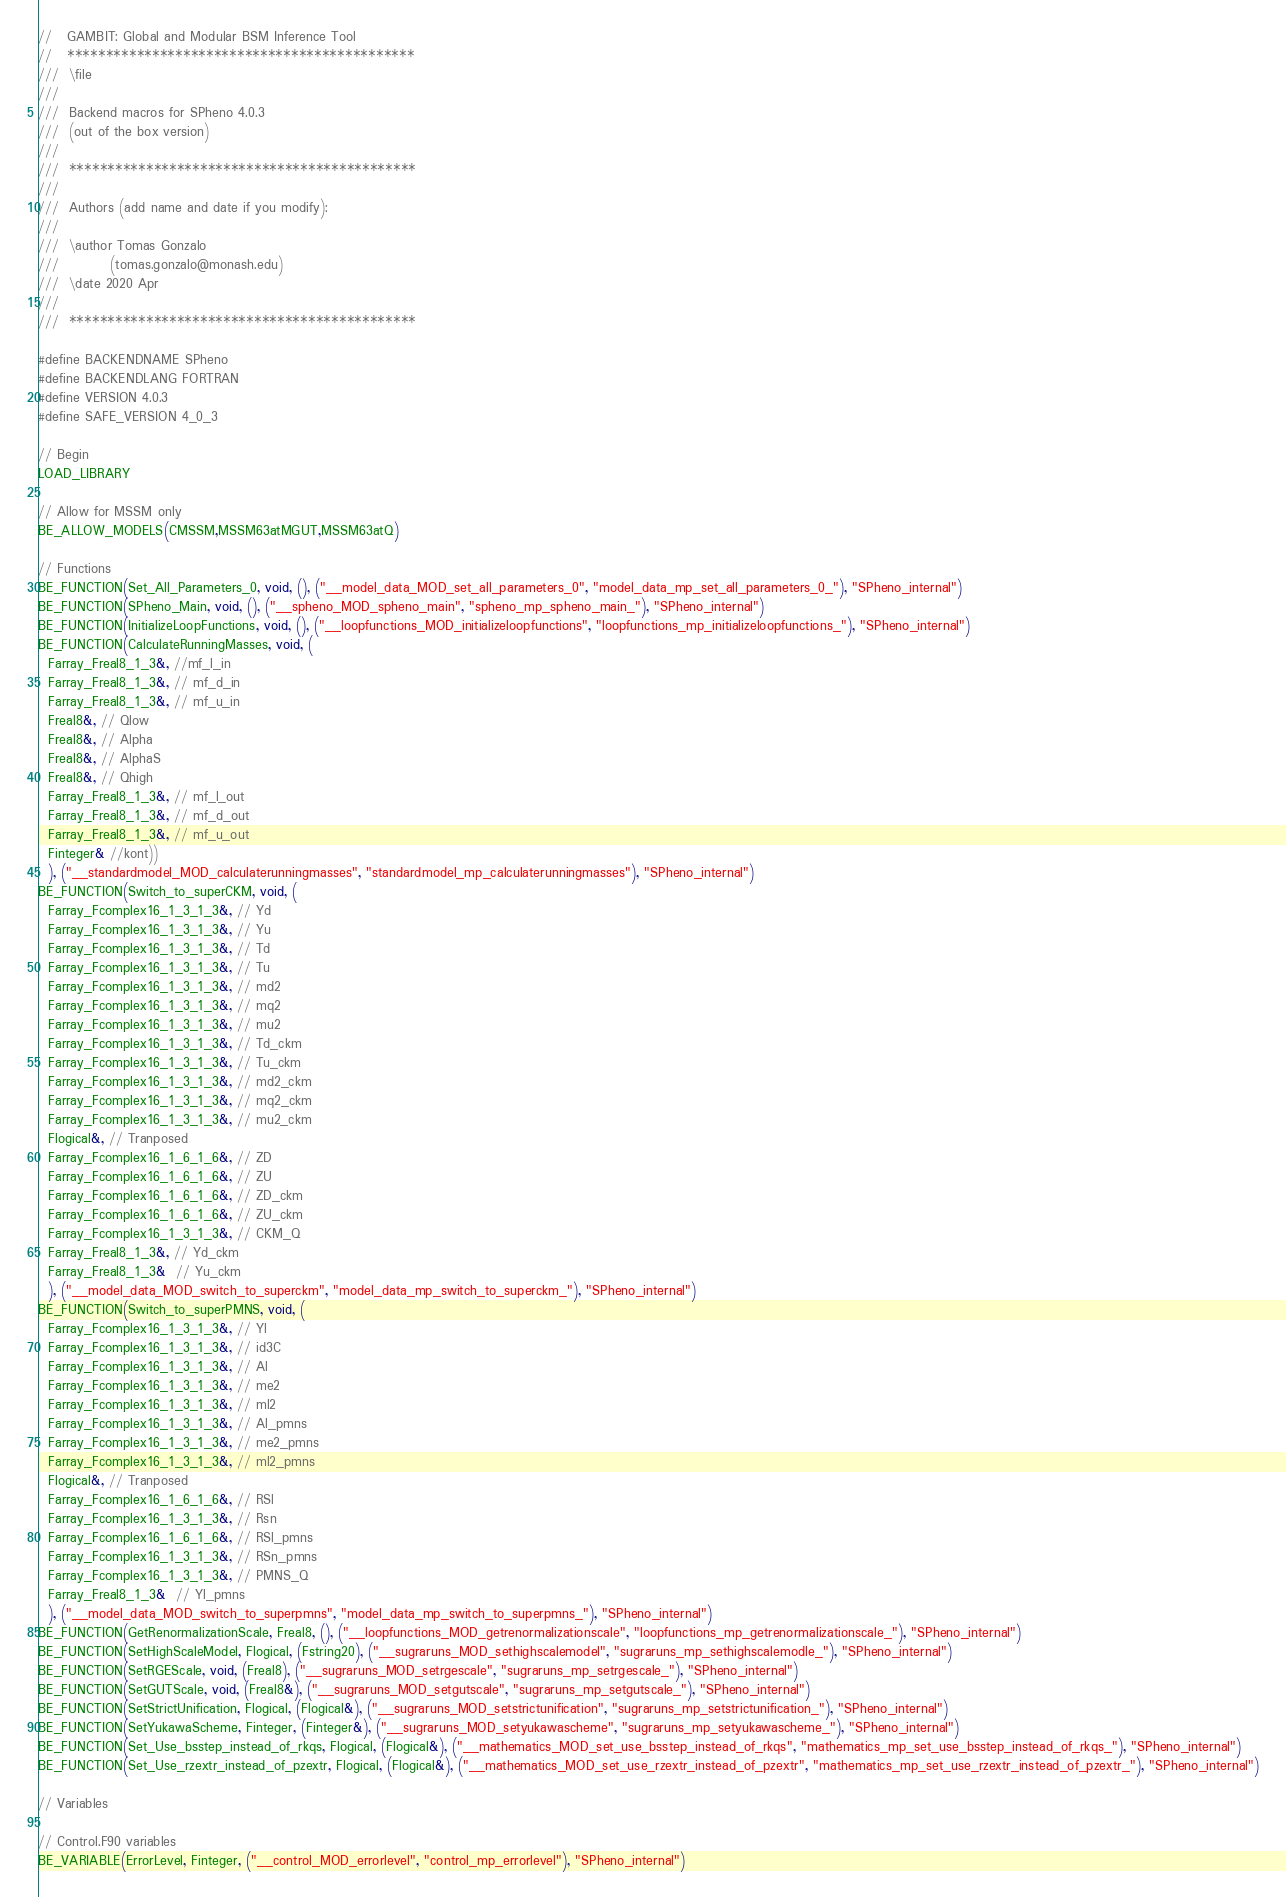Convert code to text. <code><loc_0><loc_0><loc_500><loc_500><_C++_>//   GAMBIT: Global and Modular BSM Inference Tool
//   *********************************************
///  \file
///
///  Backend macros for SPheno 4.0.3
///  (out of the box version)
///
///  *********************************************
///
///  Authors (add name and date if you modify):
///
///  \author Tomas Gonzalo
///          (tomas.gonzalo@monash.edu)
///  \date 2020 Apr
///
///  *********************************************

#define BACKENDNAME SPheno
#define BACKENDLANG FORTRAN
#define VERSION 4.0.3
#define SAFE_VERSION 4_0_3

// Begin
LOAD_LIBRARY

// Allow for MSSM only
BE_ALLOW_MODELS(CMSSM,MSSM63atMGUT,MSSM63atQ)

// Functions
BE_FUNCTION(Set_All_Parameters_0, void, (), ("__model_data_MOD_set_all_parameters_0", "model_data_mp_set_all_parameters_0_"), "SPheno_internal")
BE_FUNCTION(SPheno_Main, void, (), ("__spheno_MOD_spheno_main", "spheno_mp_spheno_main_"), "SPheno_internal")
BE_FUNCTION(InitializeLoopFunctions, void, (), ("__loopfunctions_MOD_initializeloopfunctions", "loopfunctions_mp_initializeloopfunctions_"), "SPheno_internal")
BE_FUNCTION(CalculateRunningMasses, void, (
  Farray_Freal8_1_3&, //mf_l_in
  Farray_Freal8_1_3&, // mf_d_in
  Farray_Freal8_1_3&, // mf_u_in
  Freal8&, // Qlow
  Freal8&, // Alpha
  Freal8&, // AlphaS
  Freal8&, // Qhigh
  Farray_Freal8_1_3&, // mf_l_out
  Farray_Freal8_1_3&, // mf_d_out
  Farray_Freal8_1_3&, // mf_u_out
  Finteger& //kont))
  ), ("__standardmodel_MOD_calculaterunningmasses", "standardmodel_mp_calculaterunningmasses"), "SPheno_internal")
BE_FUNCTION(Switch_to_superCKM, void, (
  Farray_Fcomplex16_1_3_1_3&, // Yd
  Farray_Fcomplex16_1_3_1_3&, // Yu
  Farray_Fcomplex16_1_3_1_3&, // Td
  Farray_Fcomplex16_1_3_1_3&, // Tu
  Farray_Fcomplex16_1_3_1_3&, // md2
  Farray_Fcomplex16_1_3_1_3&, // mq2
  Farray_Fcomplex16_1_3_1_3&, // mu2
  Farray_Fcomplex16_1_3_1_3&, // Td_ckm
  Farray_Fcomplex16_1_3_1_3&, // Tu_ckm
  Farray_Fcomplex16_1_3_1_3&, // md2_ckm
  Farray_Fcomplex16_1_3_1_3&, // mq2_ckm
  Farray_Fcomplex16_1_3_1_3&, // mu2_ckm
  Flogical&, // Tranposed
  Farray_Fcomplex16_1_6_1_6&, // ZD
  Farray_Fcomplex16_1_6_1_6&, // ZU
  Farray_Fcomplex16_1_6_1_6&, // ZD_ckm
  Farray_Fcomplex16_1_6_1_6&, // ZU_ckm
  Farray_Fcomplex16_1_3_1_3&, // CKM_Q
  Farray_Freal8_1_3&, // Yd_ckm
  Farray_Freal8_1_3&  // Yu_ckm
  ), ("__model_data_MOD_switch_to_superckm", "model_data_mp_switch_to_superckm_"), "SPheno_internal")
BE_FUNCTION(Switch_to_superPMNS, void, (
  Farray_Fcomplex16_1_3_1_3&, // Yl
  Farray_Fcomplex16_1_3_1_3&, // id3C
  Farray_Fcomplex16_1_3_1_3&, // Al
  Farray_Fcomplex16_1_3_1_3&, // me2
  Farray_Fcomplex16_1_3_1_3&, // ml2
  Farray_Fcomplex16_1_3_1_3&, // Al_pmns
  Farray_Fcomplex16_1_3_1_3&, // me2_pmns
  Farray_Fcomplex16_1_3_1_3&, // ml2_pmns
  Flogical&, // Tranposed
  Farray_Fcomplex16_1_6_1_6&, // RSl
  Farray_Fcomplex16_1_3_1_3&, // Rsn
  Farray_Fcomplex16_1_6_1_6&, // RSl_pmns
  Farray_Fcomplex16_1_3_1_3&, // RSn_pmns
  Farray_Fcomplex16_1_3_1_3&, // PMNS_Q
  Farray_Freal8_1_3&  // Yl_pmns
  ), ("__model_data_MOD_switch_to_superpmns", "model_data_mp_switch_to_superpmns_"), "SPheno_internal")
BE_FUNCTION(GetRenormalizationScale, Freal8, (), ("__loopfunctions_MOD_getrenormalizationscale", "loopfunctions_mp_getrenormalizationscale_"), "SPheno_internal")
BE_FUNCTION(SetHighScaleModel, Flogical, (Fstring20), ("__sugraruns_MOD_sethighscalemodel", "sugraruns_mp_sethighscalemodle_"), "SPheno_internal")
BE_FUNCTION(SetRGEScale, void, (Freal8), ("__sugraruns_MOD_setrgescale", "sugraruns_mp_setrgescale_"), "SPheno_internal")
BE_FUNCTION(SetGUTScale, void, (Freal8&), ("__sugraruns_MOD_setgutscale", "sugraruns_mp_setgutscale_"), "SPheno_internal")
BE_FUNCTION(SetStrictUnification, Flogical, (Flogical&), ("__sugraruns_MOD_setstrictunification", "sugraruns_mp_setstrictunification_"), "SPheno_internal")
BE_FUNCTION(SetYukawaScheme, Finteger, (Finteger&), ("__sugraruns_MOD_setyukawascheme", "sugraruns_mp_setyukawascheme_"), "SPheno_internal")
BE_FUNCTION(Set_Use_bsstep_instead_of_rkqs, Flogical, (Flogical&), ("__mathematics_MOD_set_use_bsstep_instead_of_rkqs", "mathematics_mp_set_use_bsstep_instead_of_rkqs_"), "SPheno_internal")
BE_FUNCTION(Set_Use_rzextr_instead_of_pzextr, Flogical, (Flogical&), ("__mathematics_MOD_set_use_rzextr_instead_of_pzextr", "mathematics_mp_set_use_rzextr_instead_of_pzextr_"), "SPheno_internal")

// Variables

// Control.F90 variables
BE_VARIABLE(ErrorLevel, Finteger, ("__control_MOD_errorlevel", "control_mp_errorlevel"), "SPheno_internal")</code> 